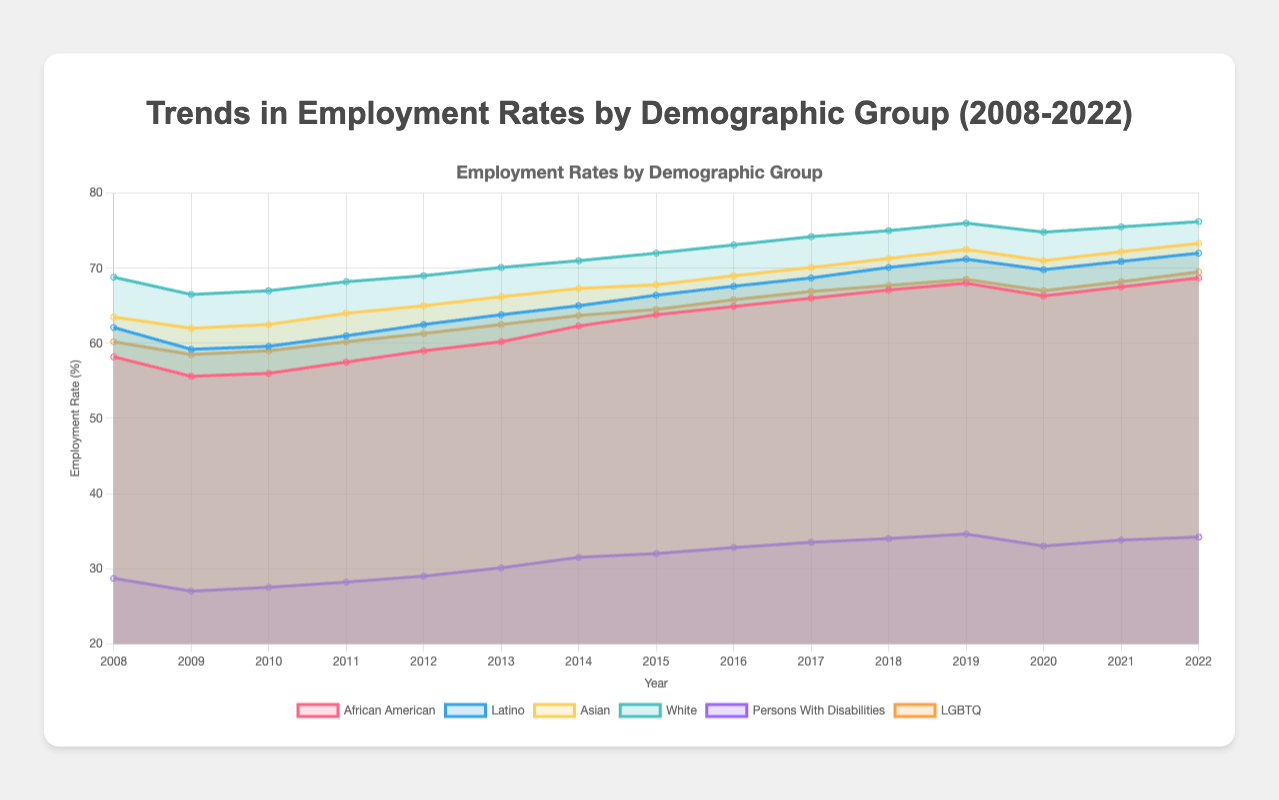What is the title of the chart? The title is displayed at the top center of the chart.
Answer: Trends in Employment Rates by Demographic Group (2008-2022) Which demographic group had the highest employment rate in 2022? Look for the highest value in 2022 among the groups compared. The value for the White group is the highest.
Answer: White What is the employment rate of Persons with Disabilities in 2012? Find the value corresponding to the year 2012 for the Persons with Disabilities group.
Answer: 29.0 How did the employment rate for the Asian group change from 2008 to 2022? Compare the values for the Asian group in 2008 and 2022 to see the difference. The rate changed from 63.5 in 2008 to 73.3 in 2022.
Answer: Increased Which group had the lowest employment rate throughout the 15 years? Check the employment rates across all years for each group. Persons with Disabilities consistently have the lowest values.
Answer: Persons with Disabilities What was the overall trend in employment rates for the Latino group from 2008 to 2022? Observe the trend line for the Latino group from start to end. The rate increased from 62.1 in 2008 to 72.0 in 2022.
Answer: Increasing Identify two demographic groups whose employment rates crossed each other at least once during these 15 years. Find where lines representing different groups intersect. Both Latino and African American groups cross from around 2013 to 2016.
Answer: Latino and African American In which year did the employment rate for the LGBTQ group exceed 65% for the first time? Look at the values for the LGBTQ group and identify when it first goes past 65%. This occurs in 2015.
Answer: 2015 